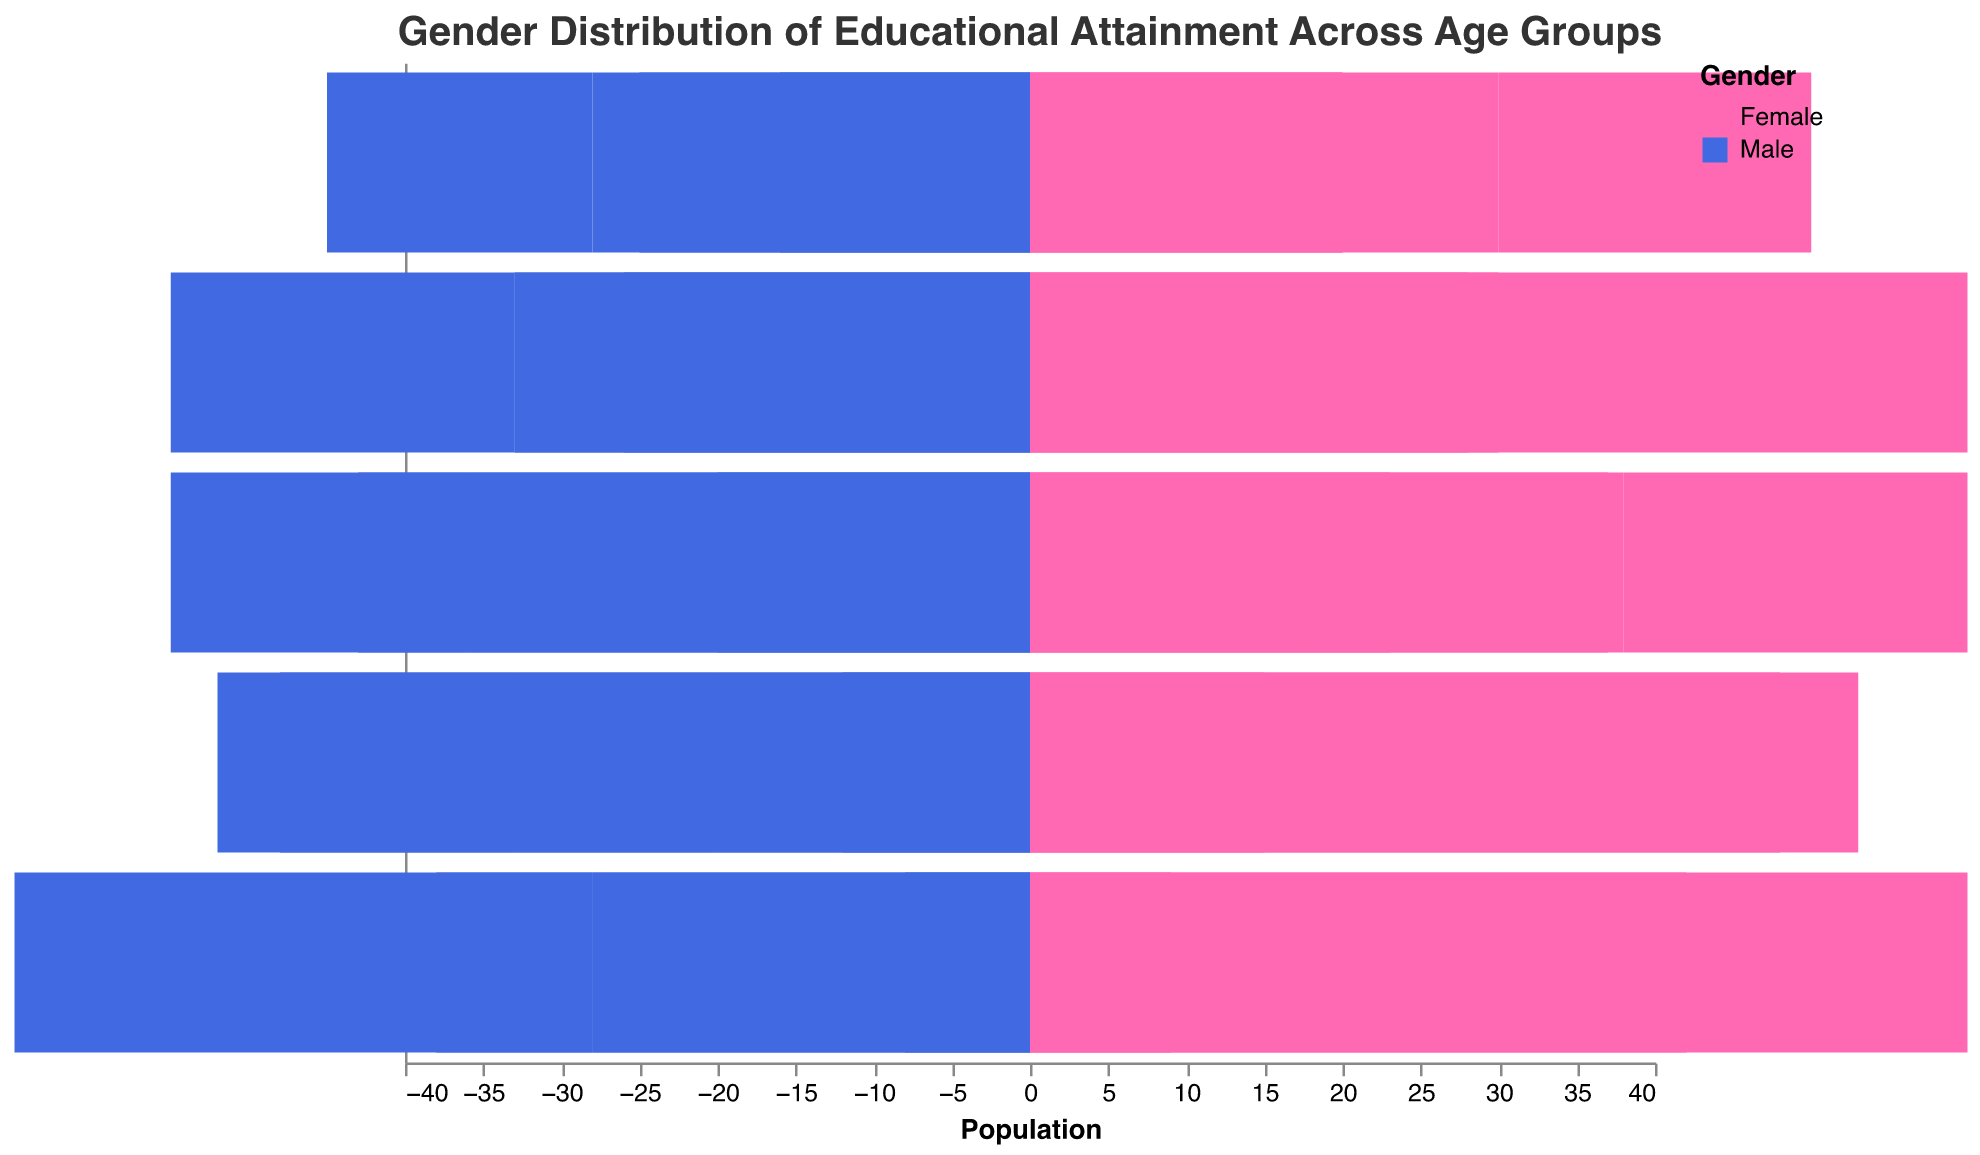What is the title of the plot? The title is usually located at the top of the plot and consists of text describing the main focus. The title here is given as: "Gender Distribution of Educational Attainment Across Age Groups"
Answer: Gender Distribution of Educational Attainment Across Age Groups How are males and females differentiated in the plot? In population pyramids, different groups are usually distinguished by colors. Males are represented by one color, and females by another. Here, the plot uses Royal blue for males and Hot pink for females.
Answer: Different colors Which gender has a higher percentage of people with primary education in the 15-24 age group in rural areas? Look at the '15-24' section and compare the primary education bar lengths for males and females in the rural category. Males in rural areas show a longer bar compared to females.
Answer: Males In the 35-44 age group, do urban females or urban males have a higher percentage of secondary education completion? Identify the secondary education bars for both urban females and urban males in the '35-44' age group. The bar for urban females is taller than the bar for urban males.
Answer: Urban females What is the total percentage of rural males in the 45-54 age group with primary education? The plot shows that for rural males in the 45-54 age group, the proportion is 32%. This information can be read directly off the length of the primary education bar.
Answer: 32% Compare the tertiary education levels for urban females across all age groups. Which age group has the highest percentage? Examine the tertiary education bars for urban females across all age groups (15-24, 25-34, 35-44, 45-54, 55-64). The highest percentage of tertiary education for urban females is in the 25-34 age group.
Answer: 25-34 age group Is there a noticeable trend in primary education levels for rural males as age increases? Observe the primary education bars for rural males across all age groups. The lengths show a pattern of increasing as the age group increases. This increasing trend is consistent from 15-24 to 55-64 age group.
Answer: Increasing trend How does the tertiary education level for rural females in the 25-34 age group compare to that of males in the same group and location? Examine the tertiary education bars for both rural females and males in the 25-34 age group. Rural females have a taller tertiary education bar than rural males.
Answer: Higher for females What is the difference in secondary education levels between urban males and rural males in the 55-64 age group? Determine the lengths of secondary education bars for urban males and rural males in the 55-64 age group. Urban males have a secondary education percentage of 28%, while rural males have a percentage of 10%. The difference is 28% - 10% = 18%.
Answer: 18% Which age group shows the largest disparity in primary education levels between rural and urban females? Compare the lengths of primary education bars for rural and urban females across all age groups. The largest disparity is found by subtracting the shorter bar from the taller bar in each age group. In the 45-54 age group, the disparity is 30% (rural) - 18% (urban) = 12%.
Answer: 45-54 age group 